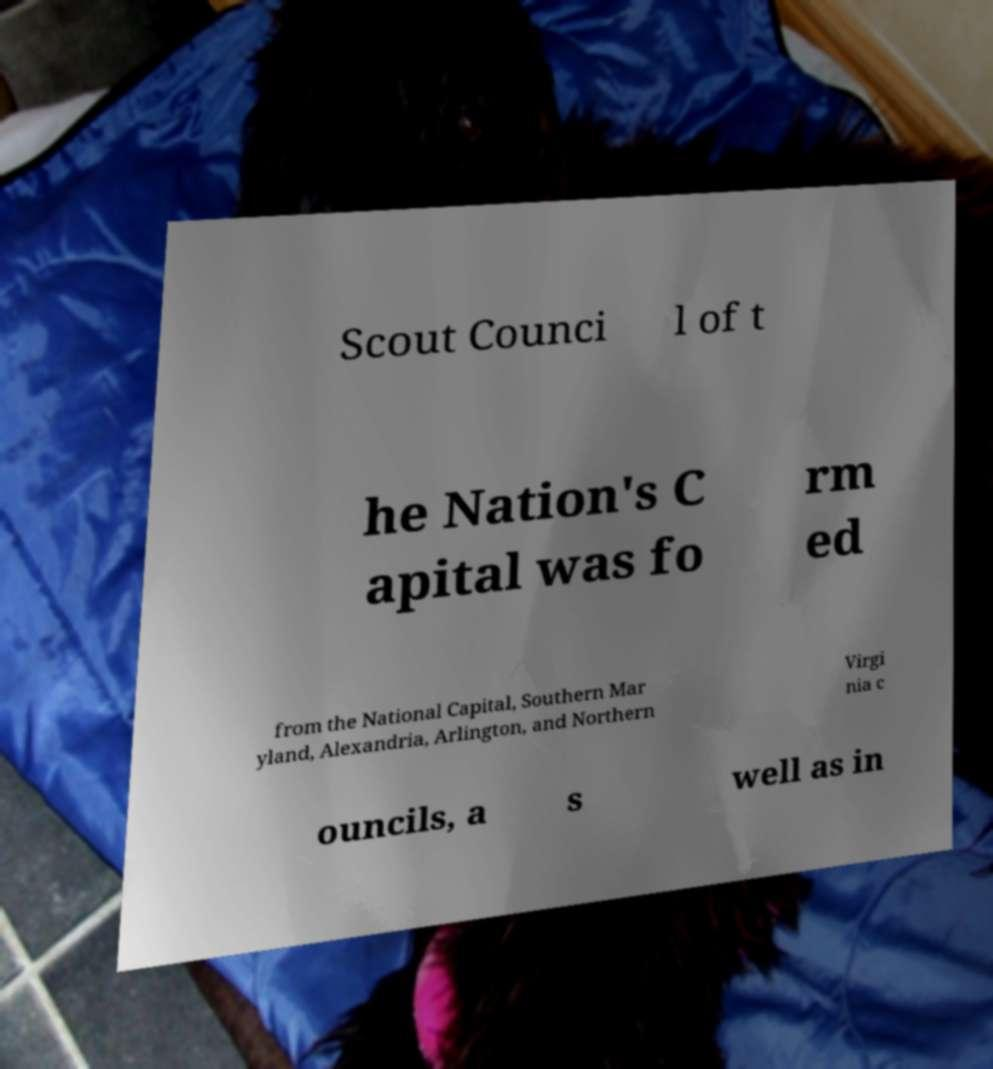What messages or text are displayed in this image? I need them in a readable, typed format. Scout Counci l of t he Nation's C apital was fo rm ed from the National Capital, Southern Mar yland, Alexandria, Arlington, and Northern Virgi nia c ouncils, a s well as in 